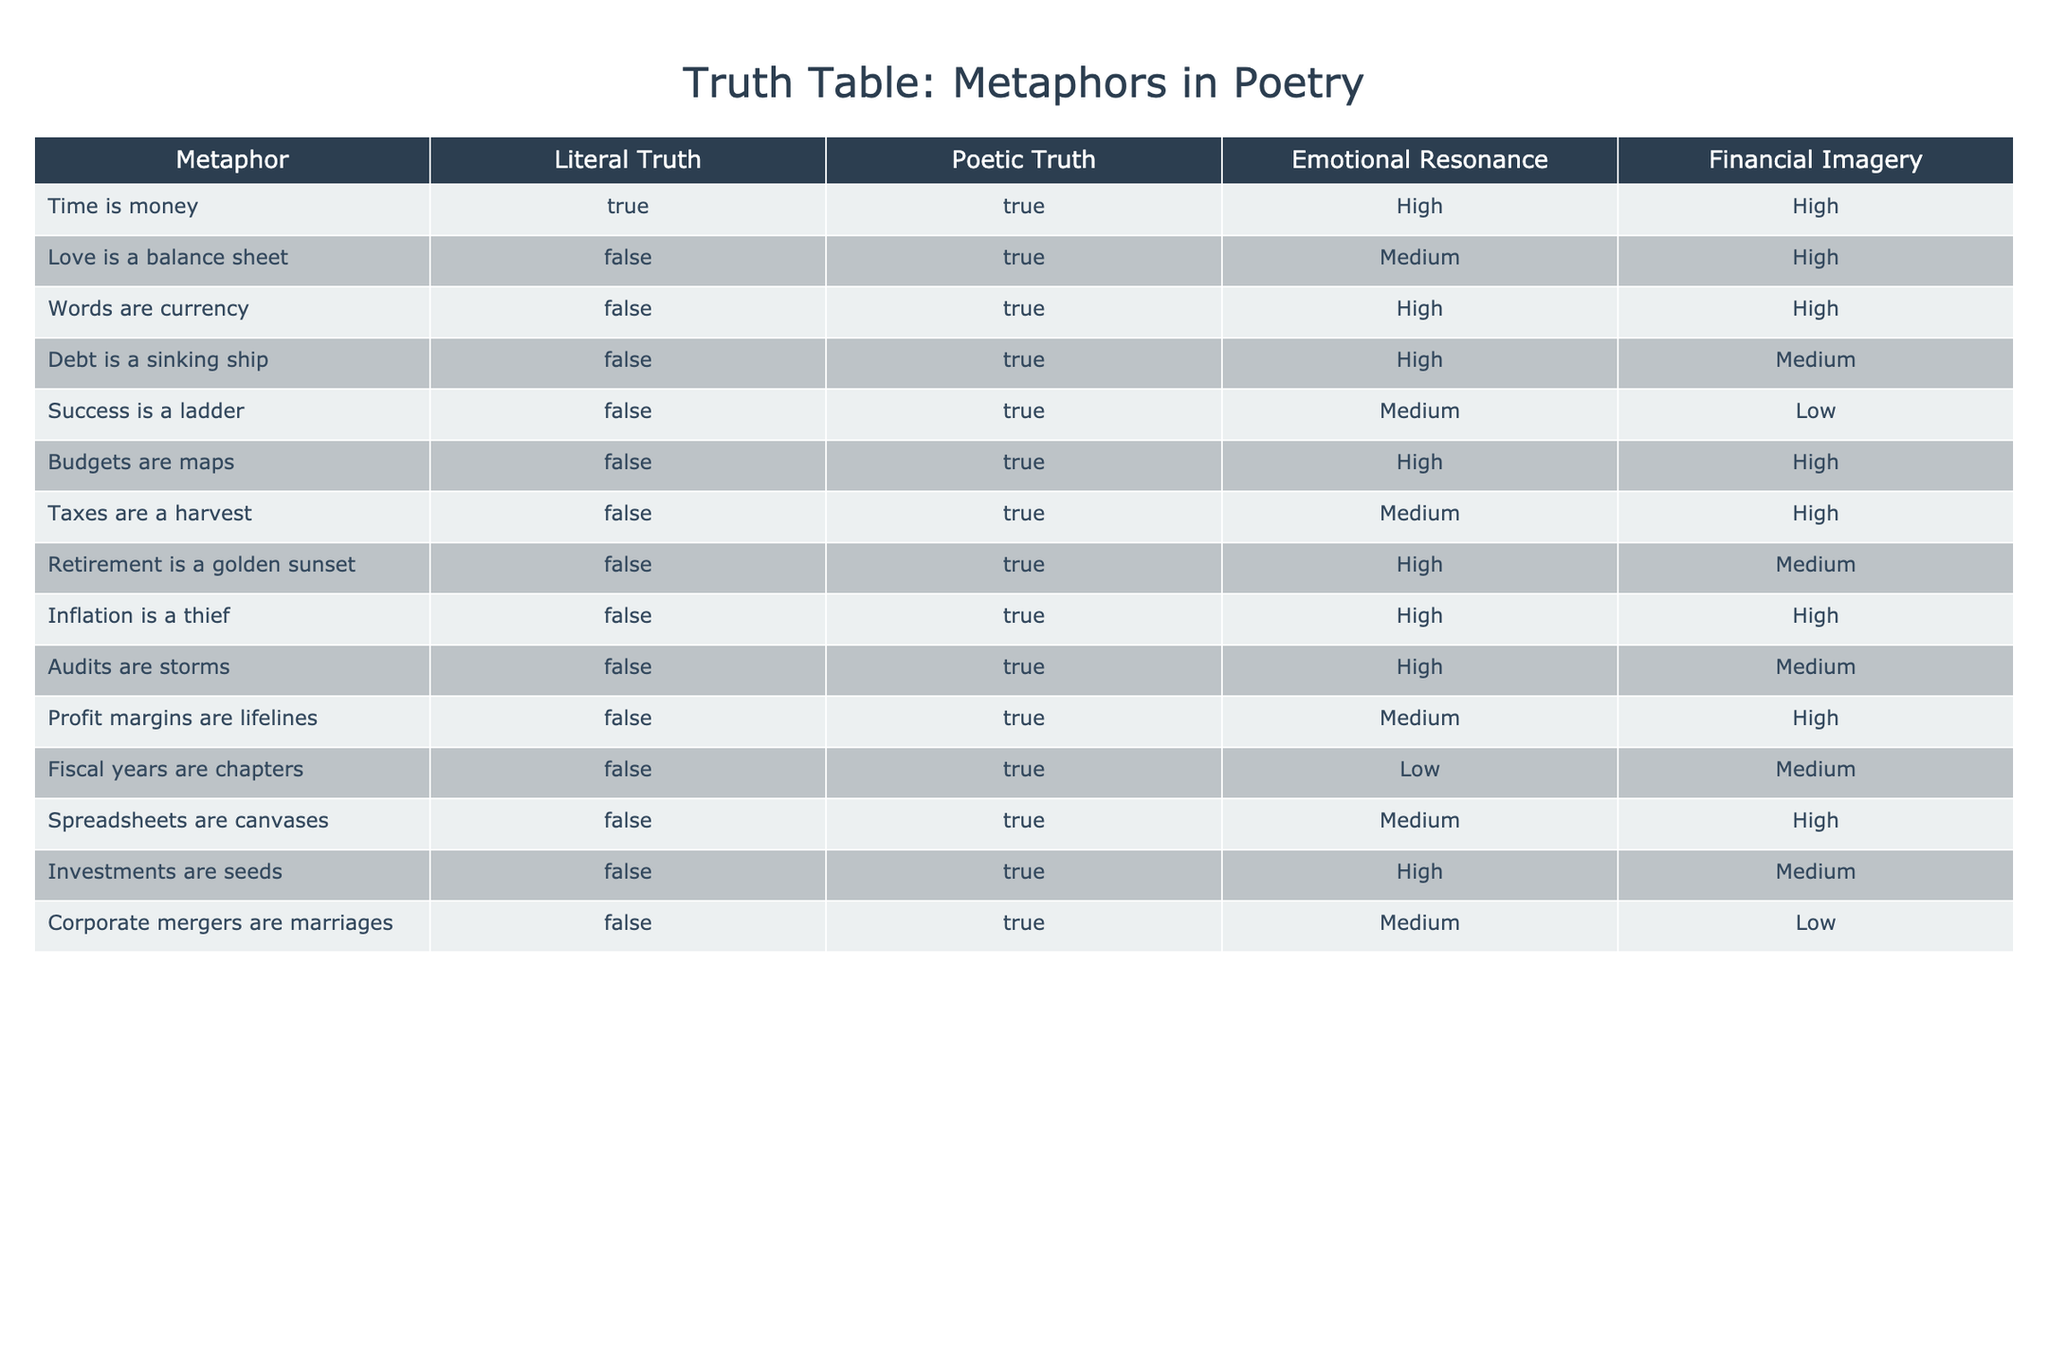What is the literal truth of the metaphor "Inflation is a thief"? The table indicates that "Inflation is a thief" has a literal truth value of False.
Answer: False How many metaphors have high emotional resonance? By examining the Emotional Resonance column, we can count the entries marked as high. The metaphors "Time is money", "Words are currency", "Debt is a sinking ship", "Budgets are maps", "Retirement is a golden sunset", "Inflation is a thief", and "Audits are storms" have high emotional resonance, totaling 6.
Answer: 6 Which metaphor has the highest poetic truth and what is its financial imagery? The table shows all listed metaphors have a poetic truth of True (with the exception of literal truth). "Time is money" has financial imagery classified as High.
Answer: "Time is money" with High financial imagery Is there a metaphor that has both a true literal truth and a high emotional resonance? Looking through the table, "Time is money" is the only one that has a true literal truth and it also has a high emotional resonance value, confirming the answer is yes.
Answer: Yes What is the average emotional resonance of all metaphors with a financial imagery of High? To calculate this, we filter for the metaphors with High financial imagery: "Time is money", "Words are currency", "Debt is a sinking ship", "Budgets are maps", "Taxes are a harvest", "Inflation is a thief", "Profit margins are lifelines", and "Spreadsheets are canvases". Since emotional resonance values are scaled: (High = 3) for 8 metaphors gives a total of 24. Dividing this by 8 results in an average of 3.
Answer: 3 